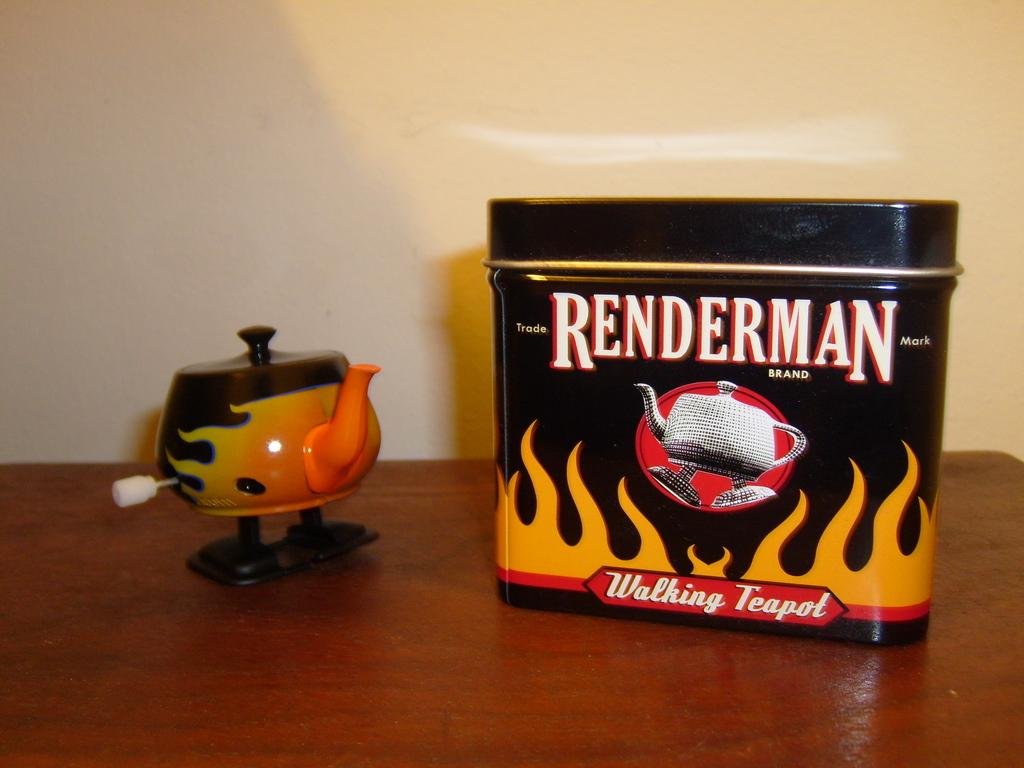What is the main object in the image? There is a table in the image. What type of toy is on the table? There is a toy in the shape of a kettle on the table. What else is on the table besides the toy? There is a box on the table. What can be seen in the background of the image? There is a wall in the background of the image. What type of sofa can be seen near the sea in the image? There is no sofa or sea present in the image; it only features a table with a toy and a box, along with a wall in the background. 